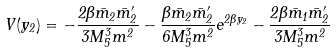<formula> <loc_0><loc_0><loc_500><loc_500>V ( y _ { 2 } ) = - \frac { 2 \beta \bar { m } _ { 2 } \bar { m } ^ { \prime } _ { 2 } } { 3 M _ { 5 } ^ { 3 } m ^ { 2 } } - \frac { \beta \bar { m } _ { 2 } \bar { m } ^ { \prime } _ { 2 } } { 6 M _ { 5 } ^ { 3 } m ^ { 2 } } e ^ { 2 \beta y _ { 2 } } - \frac { 2 \beta \bar { m } _ { 1 } \bar { m } ^ { \prime } _ { 2 } } { 3 M _ { 5 } ^ { 3 } m ^ { 2 } }</formula> 